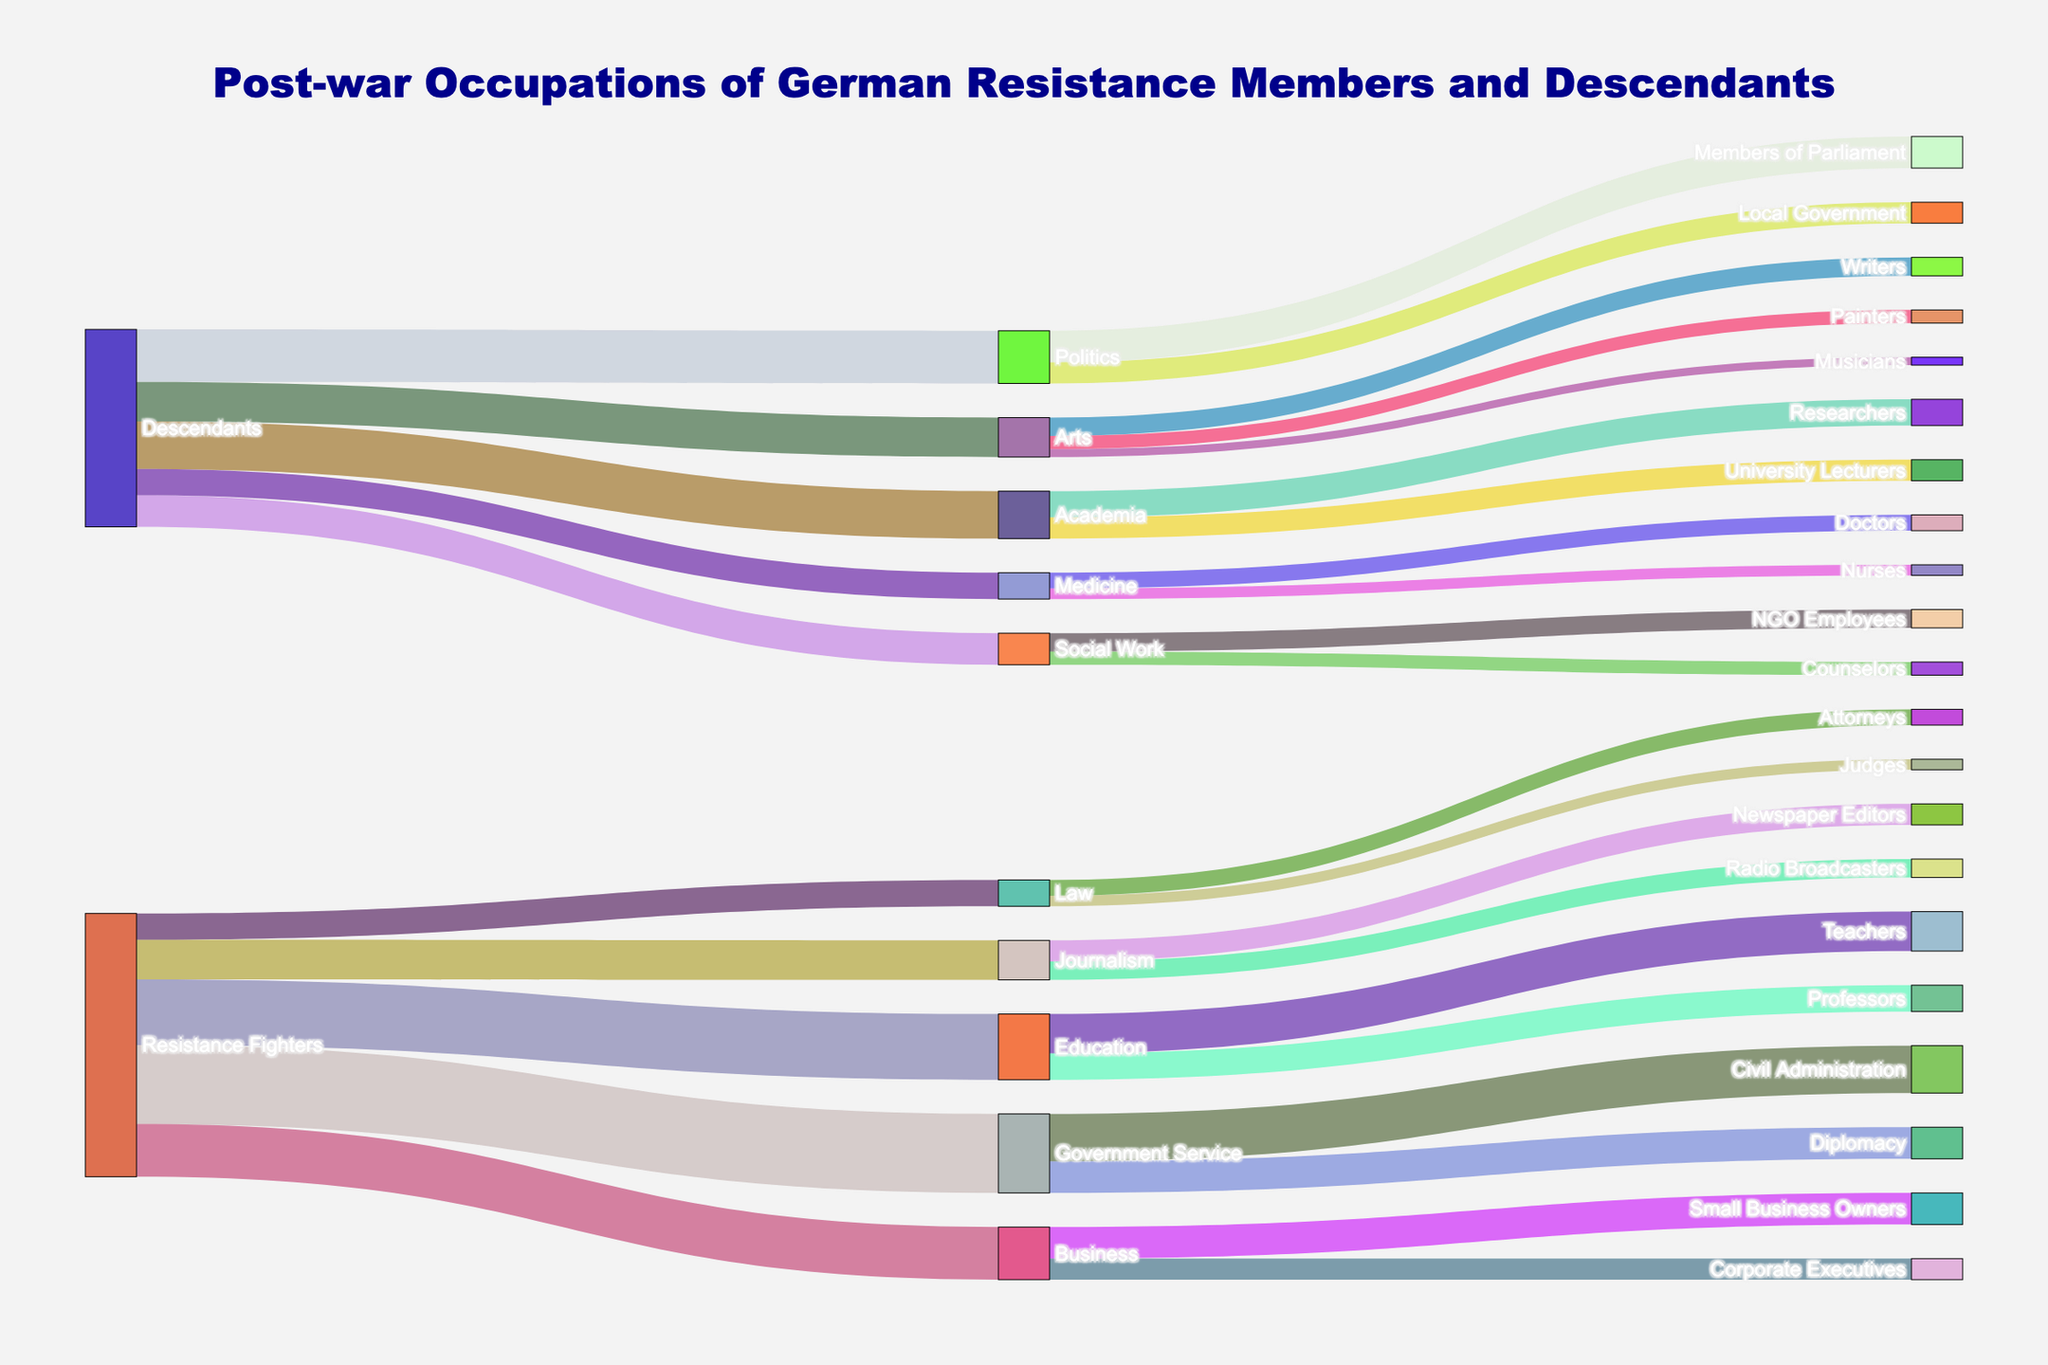What are the post-war occupations of former German resistance fighters that have the highest values? The diagram shows the flows from "Resistance Fighters" to various occupations. By looking at the width of the flows, we see that the largest flows are to "Government Service" (30), "Education" (25), "Business" (20), "Journalism" (15), and "Law" (10).
Answer: Government Service (30), Education (25), Business (20), Journalism (15), Law (10) How many descendants of resistance fighters went into academia? The diagram shows a flow from "Descendants" to "Academia" with a value. By tracing the flow, we see that 18 descendants went into academia.
Answer: 18 Which occupation categories directly split from "Government Service"? How many people went into each? By following the flow from "Government Service" to their subcategories, we can see two branches: "Diplomacy" (12) and "Civil Administration" (18).
Answer: Diplomacy (12), Civil Administration (18) Compare the number of resistance fighters who went into education versus those who went into business. The flows from "Resistance Fighters" to "Education" and "Business" are compared. "Education" has 25 while "Business" has 20. So, 25 - 20 = 5 more resistance fighters went into education than business.
Answer: 5 more into education How many descendants pursued careers in the Arts? Evaluate the flow from "Descendants" to "Arts" to see the number of people. The value for this flow is 15.
Answer: 15 Which subcategory within the "Medicine" category has the highest number of descendants? There are flows from "Medicine" to two subcategories: "Doctors" (6) and "Nurses" (4). "Doctors" has the higher value between the two.
Answer: Doctors What are the post-war careers of former resistance fighters in journalism? By inspecting the subcategories flowing from "Journalism," we see "Newspaper Editors" (8) and "Radio Broadcasters" (7).
Answer: Newspaper Editors (8), Radio Broadcasters (7) Who has more individuals, "Government Service" or their subcategory "Civil Administration"? Compare the value of "Government Service" (30) with "Civil Administration" (18). "Government Service" has more, with 30 - 18 = 12 more individuals.
Answer: Government Service, 12 more What is the total number of resistance fighters who pursued a career in law? The flow from "Resistance Fighters" to "Law" is 10. There are no subcategories to add, so the total number is 10.
Answer: 10 How many descendants work in politics compared to local government? There are two relevant flows: "Politics" to "Members of Parliament" (12) and "Politics" to "Local Government" (8). So, the total sum for politics is 12 + 8 = 20, while "Local Government" is only 8.
Answer: 20 in politics, 8 in local government 